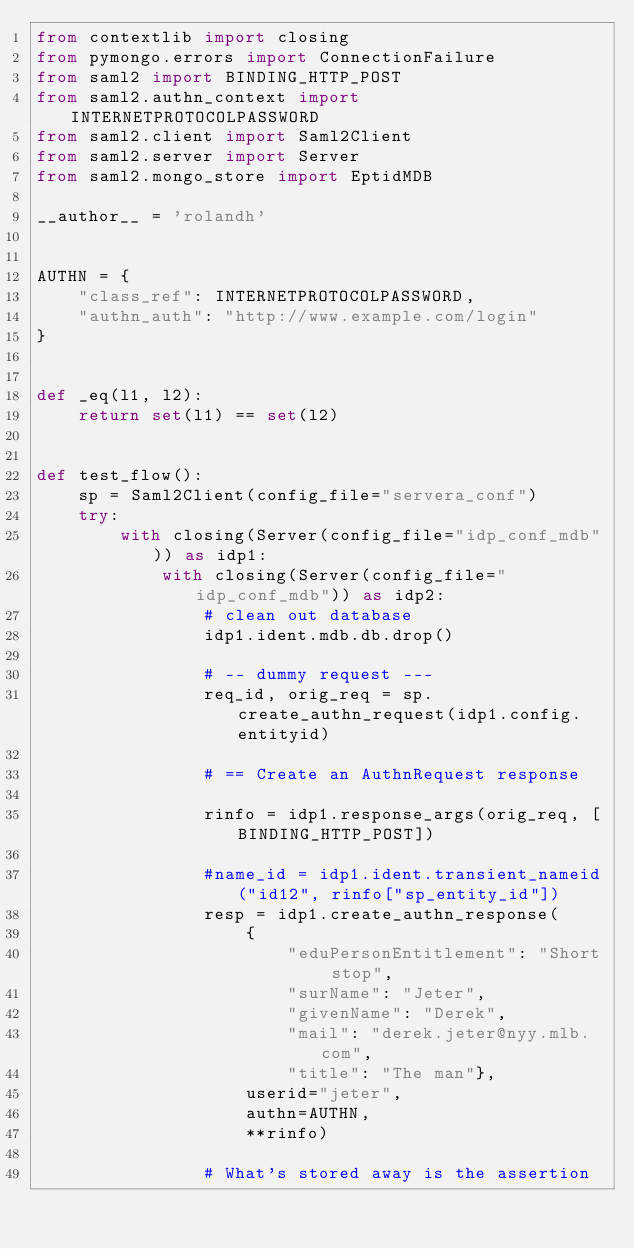<code> <loc_0><loc_0><loc_500><loc_500><_Python_>from contextlib import closing
from pymongo.errors import ConnectionFailure
from saml2 import BINDING_HTTP_POST
from saml2.authn_context import INTERNETPROTOCOLPASSWORD
from saml2.client import Saml2Client
from saml2.server import Server
from saml2.mongo_store import EptidMDB

__author__ = 'rolandh'


AUTHN = {
    "class_ref": INTERNETPROTOCOLPASSWORD,
    "authn_auth": "http://www.example.com/login"
}


def _eq(l1, l2):
    return set(l1) == set(l2)


def test_flow():
    sp = Saml2Client(config_file="servera_conf")
    try:
        with closing(Server(config_file="idp_conf_mdb")) as idp1:
            with closing(Server(config_file="idp_conf_mdb")) as idp2:
                # clean out database
                idp1.ident.mdb.db.drop()

                # -- dummy request ---
                req_id, orig_req = sp.create_authn_request(idp1.config.entityid)

                # == Create an AuthnRequest response

                rinfo = idp1.response_args(orig_req, [BINDING_HTTP_POST])

                #name_id = idp1.ident.transient_nameid("id12", rinfo["sp_entity_id"])
                resp = idp1.create_authn_response(
                    {
                        "eduPersonEntitlement": "Short stop",
                        "surName": "Jeter",
                        "givenName": "Derek",
                        "mail": "derek.jeter@nyy.mlb.com",
                        "title": "The man"},
                    userid="jeter",
                    authn=AUTHN,
                    **rinfo)

                # What's stored away is the assertion</code> 